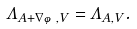Convert formula to latex. <formula><loc_0><loc_0><loc_500><loc_500>\Lambda _ { A + \nabla \varphi , V } = \Lambda _ { A , V } .</formula> 